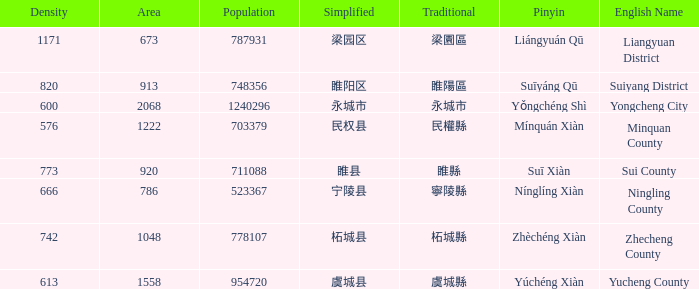What is the Pinyin for the simplified 虞城县? Yúchéng Xiàn. 